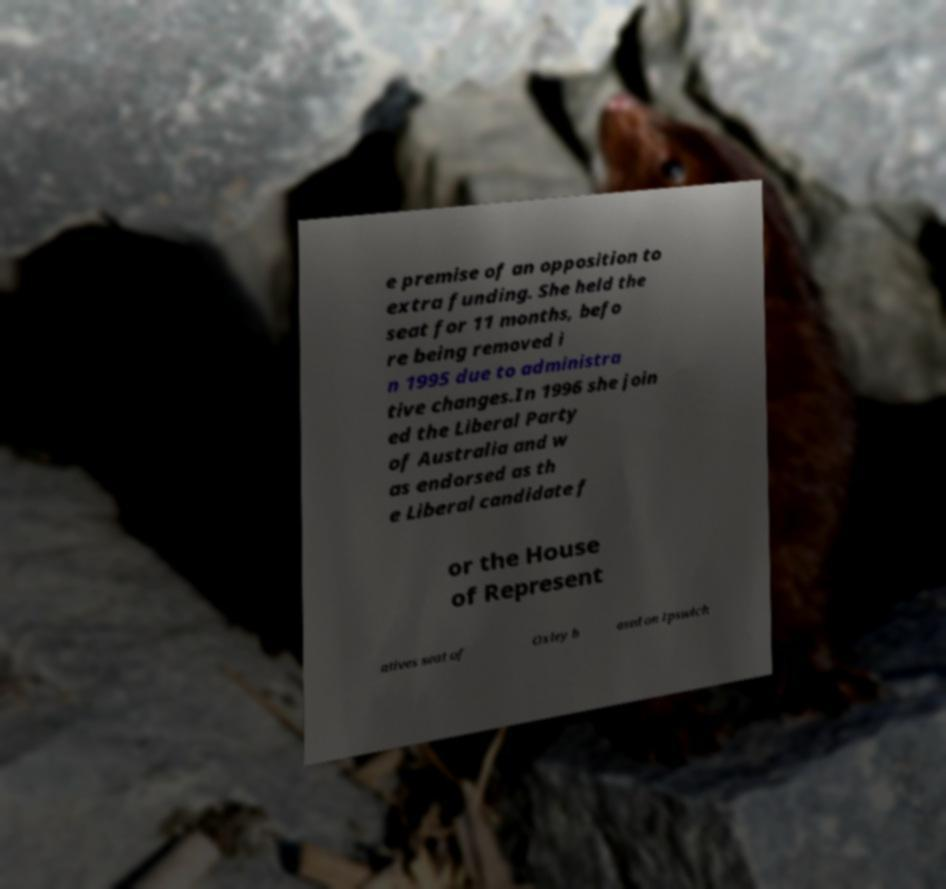Please identify and transcribe the text found in this image. e premise of an opposition to extra funding. She held the seat for 11 months, befo re being removed i n 1995 due to administra tive changes.In 1996 she join ed the Liberal Party of Australia and w as endorsed as th e Liberal candidate f or the House of Represent atives seat of Oxley b ased on Ipswich 